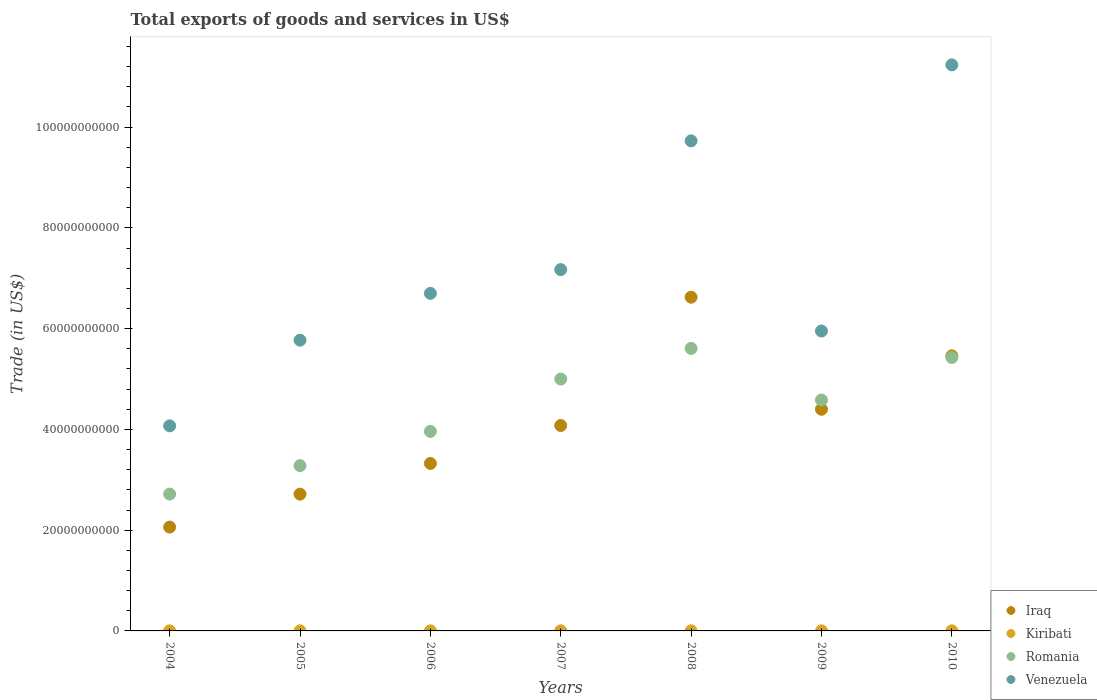How many different coloured dotlines are there?
Offer a very short reply. 4. What is the total exports of goods and services in Kiribati in 2010?
Your answer should be compact. 1.63e+07. Across all years, what is the maximum total exports of goods and services in Kiribati?
Ensure brevity in your answer.  2.08e+07. Across all years, what is the minimum total exports of goods and services in Venezuela?
Your answer should be compact. 4.07e+1. In which year was the total exports of goods and services in Venezuela minimum?
Your response must be concise. 2004. What is the total total exports of goods and services in Venezuela in the graph?
Offer a terse response. 5.06e+11. What is the difference between the total exports of goods and services in Venezuela in 2004 and that in 2007?
Make the answer very short. -3.10e+1. What is the difference between the total exports of goods and services in Iraq in 2004 and the total exports of goods and services in Kiribati in 2005?
Provide a succinct answer. 2.06e+1. What is the average total exports of goods and services in Romania per year?
Your response must be concise. 4.37e+1. In the year 2008, what is the difference between the total exports of goods and services in Iraq and total exports of goods and services in Kiribati?
Offer a terse response. 6.62e+1. In how many years, is the total exports of goods and services in Kiribati greater than 8000000000 US$?
Provide a short and direct response. 0. What is the ratio of the total exports of goods and services in Iraq in 2008 to that in 2009?
Give a very brief answer. 1.51. Is the total exports of goods and services in Romania in 2004 less than that in 2005?
Your response must be concise. Yes. What is the difference between the highest and the second highest total exports of goods and services in Venezuela?
Offer a very short reply. 1.51e+1. What is the difference between the highest and the lowest total exports of goods and services in Venezuela?
Ensure brevity in your answer.  7.16e+1. In how many years, is the total exports of goods and services in Kiribati greater than the average total exports of goods and services in Kiribati taken over all years?
Give a very brief answer. 4. Is the sum of the total exports of goods and services in Venezuela in 2009 and 2010 greater than the maximum total exports of goods and services in Romania across all years?
Ensure brevity in your answer.  Yes. Is it the case that in every year, the sum of the total exports of goods and services in Kiribati and total exports of goods and services in Venezuela  is greater than the sum of total exports of goods and services in Romania and total exports of goods and services in Iraq?
Your answer should be very brief. Yes. Is it the case that in every year, the sum of the total exports of goods and services in Romania and total exports of goods and services in Kiribati  is greater than the total exports of goods and services in Iraq?
Your answer should be very brief. No. Does the total exports of goods and services in Iraq monotonically increase over the years?
Ensure brevity in your answer.  No. Is the total exports of goods and services in Iraq strictly greater than the total exports of goods and services in Venezuela over the years?
Make the answer very short. No. How many dotlines are there?
Make the answer very short. 4. Does the graph contain any zero values?
Your answer should be compact. No. Where does the legend appear in the graph?
Provide a succinct answer. Bottom right. How many legend labels are there?
Ensure brevity in your answer.  4. What is the title of the graph?
Provide a succinct answer. Total exports of goods and services in US$. Does "Nepal" appear as one of the legend labels in the graph?
Your answer should be very brief. No. What is the label or title of the Y-axis?
Make the answer very short. Trade (in US$). What is the Trade (in US$) in Iraq in 2004?
Give a very brief answer. 2.06e+1. What is the Trade (in US$) of Kiribati in 2004?
Provide a succinct answer. 1.19e+07. What is the Trade (in US$) of Romania in 2004?
Provide a short and direct response. 2.72e+1. What is the Trade (in US$) in Venezuela in 2004?
Offer a terse response. 4.07e+1. What is the Trade (in US$) in Iraq in 2005?
Your response must be concise. 2.71e+1. What is the Trade (in US$) of Kiribati in 2005?
Your answer should be compact. 1.50e+07. What is the Trade (in US$) in Romania in 2005?
Provide a short and direct response. 3.28e+1. What is the Trade (in US$) of Venezuela in 2005?
Offer a terse response. 5.77e+1. What is the Trade (in US$) in Iraq in 2006?
Keep it short and to the point. 3.32e+1. What is the Trade (in US$) of Kiribati in 2006?
Give a very brief answer. 1.14e+07. What is the Trade (in US$) in Romania in 2006?
Offer a terse response. 3.96e+1. What is the Trade (in US$) in Venezuela in 2006?
Your answer should be compact. 6.70e+1. What is the Trade (in US$) of Iraq in 2007?
Your answer should be compact. 4.08e+1. What is the Trade (in US$) in Kiribati in 2007?
Provide a short and direct response. 2.08e+07. What is the Trade (in US$) of Romania in 2007?
Keep it short and to the point. 5.00e+1. What is the Trade (in US$) in Venezuela in 2007?
Keep it short and to the point. 7.17e+1. What is the Trade (in US$) of Iraq in 2008?
Offer a terse response. 6.62e+1. What is the Trade (in US$) of Kiribati in 2008?
Your answer should be very brief. 1.90e+07. What is the Trade (in US$) in Romania in 2008?
Keep it short and to the point. 5.61e+1. What is the Trade (in US$) in Venezuela in 2008?
Give a very brief answer. 9.73e+1. What is the Trade (in US$) of Iraq in 2009?
Your answer should be compact. 4.40e+1. What is the Trade (in US$) in Kiribati in 2009?
Offer a terse response. 1.82e+07. What is the Trade (in US$) of Romania in 2009?
Offer a very short reply. 4.58e+1. What is the Trade (in US$) in Venezuela in 2009?
Keep it short and to the point. 5.95e+1. What is the Trade (in US$) of Iraq in 2010?
Give a very brief answer. 5.46e+1. What is the Trade (in US$) in Kiribati in 2010?
Ensure brevity in your answer.  1.63e+07. What is the Trade (in US$) in Romania in 2010?
Give a very brief answer. 5.43e+1. What is the Trade (in US$) in Venezuela in 2010?
Ensure brevity in your answer.  1.12e+11. Across all years, what is the maximum Trade (in US$) in Iraq?
Your response must be concise. 6.62e+1. Across all years, what is the maximum Trade (in US$) of Kiribati?
Offer a terse response. 2.08e+07. Across all years, what is the maximum Trade (in US$) of Romania?
Make the answer very short. 5.61e+1. Across all years, what is the maximum Trade (in US$) of Venezuela?
Ensure brevity in your answer.  1.12e+11. Across all years, what is the minimum Trade (in US$) in Iraq?
Ensure brevity in your answer.  2.06e+1. Across all years, what is the minimum Trade (in US$) in Kiribati?
Your answer should be very brief. 1.14e+07. Across all years, what is the minimum Trade (in US$) in Romania?
Offer a terse response. 2.72e+1. Across all years, what is the minimum Trade (in US$) of Venezuela?
Give a very brief answer. 4.07e+1. What is the total Trade (in US$) in Iraq in the graph?
Your response must be concise. 2.87e+11. What is the total Trade (in US$) in Kiribati in the graph?
Keep it short and to the point. 1.13e+08. What is the total Trade (in US$) of Romania in the graph?
Offer a terse response. 3.06e+11. What is the total Trade (in US$) in Venezuela in the graph?
Offer a very short reply. 5.06e+11. What is the difference between the Trade (in US$) of Iraq in 2004 and that in 2005?
Your response must be concise. -6.54e+09. What is the difference between the Trade (in US$) in Kiribati in 2004 and that in 2005?
Provide a succinct answer. -3.09e+06. What is the difference between the Trade (in US$) of Romania in 2004 and that in 2005?
Your answer should be compact. -5.65e+09. What is the difference between the Trade (in US$) in Venezuela in 2004 and that in 2005?
Your answer should be very brief. -1.70e+1. What is the difference between the Trade (in US$) of Iraq in 2004 and that in 2006?
Offer a terse response. -1.26e+1. What is the difference between the Trade (in US$) of Kiribati in 2004 and that in 2006?
Keep it short and to the point. 4.48e+05. What is the difference between the Trade (in US$) of Romania in 2004 and that in 2006?
Provide a succinct answer. -1.24e+1. What is the difference between the Trade (in US$) of Venezuela in 2004 and that in 2006?
Give a very brief answer. -2.63e+1. What is the difference between the Trade (in US$) of Iraq in 2004 and that in 2007?
Keep it short and to the point. -2.02e+1. What is the difference between the Trade (in US$) of Kiribati in 2004 and that in 2007?
Your answer should be compact. -8.93e+06. What is the difference between the Trade (in US$) of Romania in 2004 and that in 2007?
Provide a succinct answer. -2.28e+1. What is the difference between the Trade (in US$) in Venezuela in 2004 and that in 2007?
Your answer should be compact. -3.10e+1. What is the difference between the Trade (in US$) of Iraq in 2004 and that in 2008?
Keep it short and to the point. -4.56e+1. What is the difference between the Trade (in US$) of Kiribati in 2004 and that in 2008?
Keep it short and to the point. -7.11e+06. What is the difference between the Trade (in US$) in Romania in 2004 and that in 2008?
Keep it short and to the point. -2.89e+1. What is the difference between the Trade (in US$) of Venezuela in 2004 and that in 2008?
Keep it short and to the point. -5.66e+1. What is the difference between the Trade (in US$) of Iraq in 2004 and that in 2009?
Give a very brief answer. -2.34e+1. What is the difference between the Trade (in US$) of Kiribati in 2004 and that in 2009?
Your answer should be compact. -6.35e+06. What is the difference between the Trade (in US$) of Romania in 2004 and that in 2009?
Give a very brief answer. -1.87e+1. What is the difference between the Trade (in US$) in Venezuela in 2004 and that in 2009?
Give a very brief answer. -1.88e+1. What is the difference between the Trade (in US$) of Iraq in 2004 and that in 2010?
Your response must be concise. -3.40e+1. What is the difference between the Trade (in US$) of Kiribati in 2004 and that in 2010?
Offer a very short reply. -4.45e+06. What is the difference between the Trade (in US$) of Romania in 2004 and that in 2010?
Your response must be concise. -2.71e+1. What is the difference between the Trade (in US$) in Venezuela in 2004 and that in 2010?
Offer a terse response. -7.16e+1. What is the difference between the Trade (in US$) of Iraq in 2005 and that in 2006?
Your answer should be very brief. -6.09e+09. What is the difference between the Trade (in US$) in Kiribati in 2005 and that in 2006?
Provide a succinct answer. 3.54e+06. What is the difference between the Trade (in US$) in Romania in 2005 and that in 2006?
Keep it short and to the point. -6.80e+09. What is the difference between the Trade (in US$) of Venezuela in 2005 and that in 2006?
Give a very brief answer. -9.29e+09. What is the difference between the Trade (in US$) of Iraq in 2005 and that in 2007?
Offer a terse response. -1.36e+1. What is the difference between the Trade (in US$) of Kiribati in 2005 and that in 2007?
Make the answer very short. -5.84e+06. What is the difference between the Trade (in US$) in Romania in 2005 and that in 2007?
Make the answer very short. -1.72e+1. What is the difference between the Trade (in US$) in Venezuela in 2005 and that in 2007?
Your response must be concise. -1.40e+1. What is the difference between the Trade (in US$) of Iraq in 2005 and that in 2008?
Your answer should be very brief. -3.91e+1. What is the difference between the Trade (in US$) of Kiribati in 2005 and that in 2008?
Give a very brief answer. -4.02e+06. What is the difference between the Trade (in US$) of Romania in 2005 and that in 2008?
Provide a short and direct response. -2.33e+1. What is the difference between the Trade (in US$) in Venezuela in 2005 and that in 2008?
Make the answer very short. -3.96e+1. What is the difference between the Trade (in US$) in Iraq in 2005 and that in 2009?
Offer a very short reply. -1.68e+1. What is the difference between the Trade (in US$) of Kiribati in 2005 and that in 2009?
Provide a succinct answer. -3.26e+06. What is the difference between the Trade (in US$) in Romania in 2005 and that in 2009?
Provide a succinct answer. -1.30e+1. What is the difference between the Trade (in US$) of Venezuela in 2005 and that in 2009?
Offer a terse response. -1.82e+09. What is the difference between the Trade (in US$) of Iraq in 2005 and that in 2010?
Keep it short and to the point. -2.74e+1. What is the difference between the Trade (in US$) of Kiribati in 2005 and that in 2010?
Your answer should be compact. -1.35e+06. What is the difference between the Trade (in US$) of Romania in 2005 and that in 2010?
Your response must be concise. -2.15e+1. What is the difference between the Trade (in US$) in Venezuela in 2005 and that in 2010?
Offer a very short reply. -5.46e+1. What is the difference between the Trade (in US$) of Iraq in 2006 and that in 2007?
Offer a very short reply. -7.54e+09. What is the difference between the Trade (in US$) of Kiribati in 2006 and that in 2007?
Your answer should be compact. -9.38e+06. What is the difference between the Trade (in US$) in Romania in 2006 and that in 2007?
Your answer should be very brief. -1.04e+1. What is the difference between the Trade (in US$) of Venezuela in 2006 and that in 2007?
Offer a very short reply. -4.71e+09. What is the difference between the Trade (in US$) in Iraq in 2006 and that in 2008?
Offer a terse response. -3.30e+1. What is the difference between the Trade (in US$) in Kiribati in 2006 and that in 2008?
Ensure brevity in your answer.  -7.56e+06. What is the difference between the Trade (in US$) of Romania in 2006 and that in 2008?
Keep it short and to the point. -1.65e+1. What is the difference between the Trade (in US$) in Venezuela in 2006 and that in 2008?
Your answer should be very brief. -3.03e+1. What is the difference between the Trade (in US$) of Iraq in 2006 and that in 2009?
Provide a short and direct response. -1.08e+1. What is the difference between the Trade (in US$) of Kiribati in 2006 and that in 2009?
Make the answer very short. -6.80e+06. What is the difference between the Trade (in US$) of Romania in 2006 and that in 2009?
Your response must be concise. -6.22e+09. What is the difference between the Trade (in US$) of Venezuela in 2006 and that in 2009?
Ensure brevity in your answer.  7.47e+09. What is the difference between the Trade (in US$) of Iraq in 2006 and that in 2010?
Keep it short and to the point. -2.14e+1. What is the difference between the Trade (in US$) in Kiribati in 2006 and that in 2010?
Your answer should be compact. -4.89e+06. What is the difference between the Trade (in US$) of Romania in 2006 and that in 2010?
Offer a terse response. -1.47e+1. What is the difference between the Trade (in US$) of Venezuela in 2006 and that in 2010?
Provide a short and direct response. -4.53e+1. What is the difference between the Trade (in US$) of Iraq in 2007 and that in 2008?
Your response must be concise. -2.55e+1. What is the difference between the Trade (in US$) in Kiribati in 2007 and that in 2008?
Provide a succinct answer. 1.82e+06. What is the difference between the Trade (in US$) in Romania in 2007 and that in 2008?
Make the answer very short. -6.08e+09. What is the difference between the Trade (in US$) in Venezuela in 2007 and that in 2008?
Your answer should be compact. -2.56e+1. What is the difference between the Trade (in US$) in Iraq in 2007 and that in 2009?
Offer a very short reply. -3.22e+09. What is the difference between the Trade (in US$) in Kiribati in 2007 and that in 2009?
Keep it short and to the point. 2.59e+06. What is the difference between the Trade (in US$) in Romania in 2007 and that in 2009?
Offer a very short reply. 4.17e+09. What is the difference between the Trade (in US$) of Venezuela in 2007 and that in 2009?
Ensure brevity in your answer.  1.22e+1. What is the difference between the Trade (in US$) in Iraq in 2007 and that in 2010?
Offer a very short reply. -1.38e+1. What is the difference between the Trade (in US$) in Kiribati in 2007 and that in 2010?
Make the answer very short. 4.49e+06. What is the difference between the Trade (in US$) of Romania in 2007 and that in 2010?
Your response must be concise. -4.27e+09. What is the difference between the Trade (in US$) in Venezuela in 2007 and that in 2010?
Give a very brief answer. -4.06e+1. What is the difference between the Trade (in US$) of Iraq in 2008 and that in 2009?
Your answer should be very brief. 2.22e+1. What is the difference between the Trade (in US$) in Kiribati in 2008 and that in 2009?
Ensure brevity in your answer.  7.68e+05. What is the difference between the Trade (in US$) of Romania in 2008 and that in 2009?
Give a very brief answer. 1.02e+1. What is the difference between the Trade (in US$) of Venezuela in 2008 and that in 2009?
Keep it short and to the point. 3.77e+1. What is the difference between the Trade (in US$) of Iraq in 2008 and that in 2010?
Your response must be concise. 1.16e+1. What is the difference between the Trade (in US$) in Kiribati in 2008 and that in 2010?
Keep it short and to the point. 2.67e+06. What is the difference between the Trade (in US$) in Romania in 2008 and that in 2010?
Provide a short and direct response. 1.81e+09. What is the difference between the Trade (in US$) in Venezuela in 2008 and that in 2010?
Offer a very short reply. -1.51e+1. What is the difference between the Trade (in US$) of Iraq in 2009 and that in 2010?
Ensure brevity in your answer.  -1.06e+1. What is the difference between the Trade (in US$) in Kiribati in 2009 and that in 2010?
Provide a short and direct response. 1.90e+06. What is the difference between the Trade (in US$) of Romania in 2009 and that in 2010?
Your answer should be very brief. -8.44e+09. What is the difference between the Trade (in US$) in Venezuela in 2009 and that in 2010?
Your response must be concise. -5.28e+1. What is the difference between the Trade (in US$) in Iraq in 2004 and the Trade (in US$) in Kiribati in 2005?
Your response must be concise. 2.06e+1. What is the difference between the Trade (in US$) in Iraq in 2004 and the Trade (in US$) in Romania in 2005?
Your answer should be compact. -1.22e+1. What is the difference between the Trade (in US$) of Iraq in 2004 and the Trade (in US$) of Venezuela in 2005?
Your response must be concise. -3.71e+1. What is the difference between the Trade (in US$) in Kiribati in 2004 and the Trade (in US$) in Romania in 2005?
Ensure brevity in your answer.  -3.28e+1. What is the difference between the Trade (in US$) in Kiribati in 2004 and the Trade (in US$) in Venezuela in 2005?
Ensure brevity in your answer.  -5.77e+1. What is the difference between the Trade (in US$) of Romania in 2004 and the Trade (in US$) of Venezuela in 2005?
Offer a terse response. -3.05e+1. What is the difference between the Trade (in US$) in Iraq in 2004 and the Trade (in US$) in Kiribati in 2006?
Ensure brevity in your answer.  2.06e+1. What is the difference between the Trade (in US$) of Iraq in 2004 and the Trade (in US$) of Romania in 2006?
Give a very brief answer. -1.90e+1. What is the difference between the Trade (in US$) in Iraq in 2004 and the Trade (in US$) in Venezuela in 2006?
Provide a short and direct response. -4.64e+1. What is the difference between the Trade (in US$) in Kiribati in 2004 and the Trade (in US$) in Romania in 2006?
Offer a terse response. -3.96e+1. What is the difference between the Trade (in US$) of Kiribati in 2004 and the Trade (in US$) of Venezuela in 2006?
Your answer should be compact. -6.70e+1. What is the difference between the Trade (in US$) in Romania in 2004 and the Trade (in US$) in Venezuela in 2006?
Keep it short and to the point. -3.98e+1. What is the difference between the Trade (in US$) of Iraq in 2004 and the Trade (in US$) of Kiribati in 2007?
Give a very brief answer. 2.06e+1. What is the difference between the Trade (in US$) of Iraq in 2004 and the Trade (in US$) of Romania in 2007?
Provide a succinct answer. -2.94e+1. What is the difference between the Trade (in US$) in Iraq in 2004 and the Trade (in US$) in Venezuela in 2007?
Make the answer very short. -5.11e+1. What is the difference between the Trade (in US$) of Kiribati in 2004 and the Trade (in US$) of Romania in 2007?
Your response must be concise. -5.00e+1. What is the difference between the Trade (in US$) in Kiribati in 2004 and the Trade (in US$) in Venezuela in 2007?
Keep it short and to the point. -7.17e+1. What is the difference between the Trade (in US$) of Romania in 2004 and the Trade (in US$) of Venezuela in 2007?
Offer a very short reply. -4.46e+1. What is the difference between the Trade (in US$) in Iraq in 2004 and the Trade (in US$) in Kiribati in 2008?
Provide a short and direct response. 2.06e+1. What is the difference between the Trade (in US$) in Iraq in 2004 and the Trade (in US$) in Romania in 2008?
Offer a very short reply. -3.55e+1. What is the difference between the Trade (in US$) of Iraq in 2004 and the Trade (in US$) of Venezuela in 2008?
Make the answer very short. -7.67e+1. What is the difference between the Trade (in US$) in Kiribati in 2004 and the Trade (in US$) in Romania in 2008?
Offer a very short reply. -5.61e+1. What is the difference between the Trade (in US$) of Kiribati in 2004 and the Trade (in US$) of Venezuela in 2008?
Offer a terse response. -9.73e+1. What is the difference between the Trade (in US$) in Romania in 2004 and the Trade (in US$) in Venezuela in 2008?
Ensure brevity in your answer.  -7.01e+1. What is the difference between the Trade (in US$) of Iraq in 2004 and the Trade (in US$) of Kiribati in 2009?
Provide a short and direct response. 2.06e+1. What is the difference between the Trade (in US$) in Iraq in 2004 and the Trade (in US$) in Romania in 2009?
Your response must be concise. -2.52e+1. What is the difference between the Trade (in US$) in Iraq in 2004 and the Trade (in US$) in Venezuela in 2009?
Your response must be concise. -3.89e+1. What is the difference between the Trade (in US$) in Kiribati in 2004 and the Trade (in US$) in Romania in 2009?
Provide a succinct answer. -4.58e+1. What is the difference between the Trade (in US$) in Kiribati in 2004 and the Trade (in US$) in Venezuela in 2009?
Offer a very short reply. -5.95e+1. What is the difference between the Trade (in US$) of Romania in 2004 and the Trade (in US$) of Venezuela in 2009?
Ensure brevity in your answer.  -3.24e+1. What is the difference between the Trade (in US$) in Iraq in 2004 and the Trade (in US$) in Kiribati in 2010?
Provide a succinct answer. 2.06e+1. What is the difference between the Trade (in US$) of Iraq in 2004 and the Trade (in US$) of Romania in 2010?
Your response must be concise. -3.37e+1. What is the difference between the Trade (in US$) in Iraq in 2004 and the Trade (in US$) in Venezuela in 2010?
Offer a terse response. -9.17e+1. What is the difference between the Trade (in US$) in Kiribati in 2004 and the Trade (in US$) in Romania in 2010?
Keep it short and to the point. -5.43e+1. What is the difference between the Trade (in US$) of Kiribati in 2004 and the Trade (in US$) of Venezuela in 2010?
Give a very brief answer. -1.12e+11. What is the difference between the Trade (in US$) in Romania in 2004 and the Trade (in US$) in Venezuela in 2010?
Make the answer very short. -8.52e+1. What is the difference between the Trade (in US$) in Iraq in 2005 and the Trade (in US$) in Kiribati in 2006?
Your response must be concise. 2.71e+1. What is the difference between the Trade (in US$) in Iraq in 2005 and the Trade (in US$) in Romania in 2006?
Offer a very short reply. -1.25e+1. What is the difference between the Trade (in US$) of Iraq in 2005 and the Trade (in US$) of Venezuela in 2006?
Make the answer very short. -3.99e+1. What is the difference between the Trade (in US$) in Kiribati in 2005 and the Trade (in US$) in Romania in 2006?
Make the answer very short. -3.96e+1. What is the difference between the Trade (in US$) of Kiribati in 2005 and the Trade (in US$) of Venezuela in 2006?
Give a very brief answer. -6.70e+1. What is the difference between the Trade (in US$) in Romania in 2005 and the Trade (in US$) in Venezuela in 2006?
Offer a terse response. -3.42e+1. What is the difference between the Trade (in US$) in Iraq in 2005 and the Trade (in US$) in Kiribati in 2007?
Ensure brevity in your answer.  2.71e+1. What is the difference between the Trade (in US$) in Iraq in 2005 and the Trade (in US$) in Romania in 2007?
Offer a terse response. -2.28e+1. What is the difference between the Trade (in US$) of Iraq in 2005 and the Trade (in US$) of Venezuela in 2007?
Ensure brevity in your answer.  -4.46e+1. What is the difference between the Trade (in US$) of Kiribati in 2005 and the Trade (in US$) of Romania in 2007?
Provide a succinct answer. -5.00e+1. What is the difference between the Trade (in US$) of Kiribati in 2005 and the Trade (in US$) of Venezuela in 2007?
Offer a terse response. -7.17e+1. What is the difference between the Trade (in US$) of Romania in 2005 and the Trade (in US$) of Venezuela in 2007?
Ensure brevity in your answer.  -3.89e+1. What is the difference between the Trade (in US$) of Iraq in 2005 and the Trade (in US$) of Kiribati in 2008?
Your answer should be compact. 2.71e+1. What is the difference between the Trade (in US$) of Iraq in 2005 and the Trade (in US$) of Romania in 2008?
Your answer should be compact. -2.89e+1. What is the difference between the Trade (in US$) of Iraq in 2005 and the Trade (in US$) of Venezuela in 2008?
Provide a succinct answer. -7.01e+1. What is the difference between the Trade (in US$) in Kiribati in 2005 and the Trade (in US$) in Romania in 2008?
Make the answer very short. -5.61e+1. What is the difference between the Trade (in US$) of Kiribati in 2005 and the Trade (in US$) of Venezuela in 2008?
Make the answer very short. -9.73e+1. What is the difference between the Trade (in US$) in Romania in 2005 and the Trade (in US$) in Venezuela in 2008?
Give a very brief answer. -6.45e+1. What is the difference between the Trade (in US$) in Iraq in 2005 and the Trade (in US$) in Kiribati in 2009?
Your answer should be compact. 2.71e+1. What is the difference between the Trade (in US$) of Iraq in 2005 and the Trade (in US$) of Romania in 2009?
Keep it short and to the point. -1.87e+1. What is the difference between the Trade (in US$) of Iraq in 2005 and the Trade (in US$) of Venezuela in 2009?
Your answer should be compact. -3.24e+1. What is the difference between the Trade (in US$) of Kiribati in 2005 and the Trade (in US$) of Romania in 2009?
Keep it short and to the point. -4.58e+1. What is the difference between the Trade (in US$) in Kiribati in 2005 and the Trade (in US$) in Venezuela in 2009?
Make the answer very short. -5.95e+1. What is the difference between the Trade (in US$) of Romania in 2005 and the Trade (in US$) of Venezuela in 2009?
Your answer should be very brief. -2.67e+1. What is the difference between the Trade (in US$) of Iraq in 2005 and the Trade (in US$) of Kiribati in 2010?
Your response must be concise. 2.71e+1. What is the difference between the Trade (in US$) of Iraq in 2005 and the Trade (in US$) of Romania in 2010?
Keep it short and to the point. -2.71e+1. What is the difference between the Trade (in US$) of Iraq in 2005 and the Trade (in US$) of Venezuela in 2010?
Keep it short and to the point. -8.52e+1. What is the difference between the Trade (in US$) in Kiribati in 2005 and the Trade (in US$) in Romania in 2010?
Your answer should be compact. -5.43e+1. What is the difference between the Trade (in US$) of Kiribati in 2005 and the Trade (in US$) of Venezuela in 2010?
Provide a short and direct response. -1.12e+11. What is the difference between the Trade (in US$) in Romania in 2005 and the Trade (in US$) in Venezuela in 2010?
Provide a short and direct response. -7.95e+1. What is the difference between the Trade (in US$) in Iraq in 2006 and the Trade (in US$) in Kiribati in 2007?
Your response must be concise. 3.32e+1. What is the difference between the Trade (in US$) in Iraq in 2006 and the Trade (in US$) in Romania in 2007?
Your answer should be compact. -1.68e+1. What is the difference between the Trade (in US$) of Iraq in 2006 and the Trade (in US$) of Venezuela in 2007?
Ensure brevity in your answer.  -3.85e+1. What is the difference between the Trade (in US$) of Kiribati in 2006 and the Trade (in US$) of Romania in 2007?
Make the answer very short. -5.00e+1. What is the difference between the Trade (in US$) of Kiribati in 2006 and the Trade (in US$) of Venezuela in 2007?
Your response must be concise. -7.17e+1. What is the difference between the Trade (in US$) of Romania in 2006 and the Trade (in US$) of Venezuela in 2007?
Give a very brief answer. -3.21e+1. What is the difference between the Trade (in US$) of Iraq in 2006 and the Trade (in US$) of Kiribati in 2008?
Make the answer very short. 3.32e+1. What is the difference between the Trade (in US$) in Iraq in 2006 and the Trade (in US$) in Romania in 2008?
Your answer should be very brief. -2.28e+1. What is the difference between the Trade (in US$) of Iraq in 2006 and the Trade (in US$) of Venezuela in 2008?
Provide a short and direct response. -6.40e+1. What is the difference between the Trade (in US$) in Kiribati in 2006 and the Trade (in US$) in Romania in 2008?
Offer a terse response. -5.61e+1. What is the difference between the Trade (in US$) in Kiribati in 2006 and the Trade (in US$) in Venezuela in 2008?
Provide a short and direct response. -9.73e+1. What is the difference between the Trade (in US$) of Romania in 2006 and the Trade (in US$) of Venezuela in 2008?
Ensure brevity in your answer.  -5.77e+1. What is the difference between the Trade (in US$) of Iraq in 2006 and the Trade (in US$) of Kiribati in 2009?
Ensure brevity in your answer.  3.32e+1. What is the difference between the Trade (in US$) in Iraq in 2006 and the Trade (in US$) in Romania in 2009?
Your answer should be very brief. -1.26e+1. What is the difference between the Trade (in US$) in Iraq in 2006 and the Trade (in US$) in Venezuela in 2009?
Your answer should be compact. -2.63e+1. What is the difference between the Trade (in US$) of Kiribati in 2006 and the Trade (in US$) of Romania in 2009?
Your answer should be very brief. -4.58e+1. What is the difference between the Trade (in US$) of Kiribati in 2006 and the Trade (in US$) of Venezuela in 2009?
Your answer should be compact. -5.95e+1. What is the difference between the Trade (in US$) of Romania in 2006 and the Trade (in US$) of Venezuela in 2009?
Offer a terse response. -1.99e+1. What is the difference between the Trade (in US$) in Iraq in 2006 and the Trade (in US$) in Kiribati in 2010?
Give a very brief answer. 3.32e+1. What is the difference between the Trade (in US$) in Iraq in 2006 and the Trade (in US$) in Romania in 2010?
Provide a short and direct response. -2.10e+1. What is the difference between the Trade (in US$) of Iraq in 2006 and the Trade (in US$) of Venezuela in 2010?
Give a very brief answer. -7.91e+1. What is the difference between the Trade (in US$) of Kiribati in 2006 and the Trade (in US$) of Romania in 2010?
Make the answer very short. -5.43e+1. What is the difference between the Trade (in US$) in Kiribati in 2006 and the Trade (in US$) in Venezuela in 2010?
Ensure brevity in your answer.  -1.12e+11. What is the difference between the Trade (in US$) in Romania in 2006 and the Trade (in US$) in Venezuela in 2010?
Your answer should be very brief. -7.27e+1. What is the difference between the Trade (in US$) in Iraq in 2007 and the Trade (in US$) in Kiribati in 2008?
Ensure brevity in your answer.  4.08e+1. What is the difference between the Trade (in US$) of Iraq in 2007 and the Trade (in US$) of Romania in 2008?
Your answer should be very brief. -1.53e+1. What is the difference between the Trade (in US$) in Iraq in 2007 and the Trade (in US$) in Venezuela in 2008?
Keep it short and to the point. -5.65e+1. What is the difference between the Trade (in US$) in Kiribati in 2007 and the Trade (in US$) in Romania in 2008?
Ensure brevity in your answer.  -5.61e+1. What is the difference between the Trade (in US$) in Kiribati in 2007 and the Trade (in US$) in Venezuela in 2008?
Offer a terse response. -9.73e+1. What is the difference between the Trade (in US$) of Romania in 2007 and the Trade (in US$) of Venezuela in 2008?
Ensure brevity in your answer.  -4.73e+1. What is the difference between the Trade (in US$) in Iraq in 2007 and the Trade (in US$) in Kiribati in 2009?
Your response must be concise. 4.08e+1. What is the difference between the Trade (in US$) in Iraq in 2007 and the Trade (in US$) in Romania in 2009?
Keep it short and to the point. -5.05e+09. What is the difference between the Trade (in US$) in Iraq in 2007 and the Trade (in US$) in Venezuela in 2009?
Keep it short and to the point. -1.88e+1. What is the difference between the Trade (in US$) of Kiribati in 2007 and the Trade (in US$) of Romania in 2009?
Your answer should be compact. -4.58e+1. What is the difference between the Trade (in US$) of Kiribati in 2007 and the Trade (in US$) of Venezuela in 2009?
Your answer should be compact. -5.95e+1. What is the difference between the Trade (in US$) in Romania in 2007 and the Trade (in US$) in Venezuela in 2009?
Offer a terse response. -9.54e+09. What is the difference between the Trade (in US$) in Iraq in 2007 and the Trade (in US$) in Kiribati in 2010?
Your response must be concise. 4.08e+1. What is the difference between the Trade (in US$) of Iraq in 2007 and the Trade (in US$) of Romania in 2010?
Your answer should be compact. -1.35e+1. What is the difference between the Trade (in US$) of Iraq in 2007 and the Trade (in US$) of Venezuela in 2010?
Offer a terse response. -7.16e+1. What is the difference between the Trade (in US$) in Kiribati in 2007 and the Trade (in US$) in Romania in 2010?
Offer a very short reply. -5.42e+1. What is the difference between the Trade (in US$) in Kiribati in 2007 and the Trade (in US$) in Venezuela in 2010?
Offer a very short reply. -1.12e+11. What is the difference between the Trade (in US$) in Romania in 2007 and the Trade (in US$) in Venezuela in 2010?
Ensure brevity in your answer.  -6.24e+1. What is the difference between the Trade (in US$) of Iraq in 2008 and the Trade (in US$) of Kiribati in 2009?
Keep it short and to the point. 6.62e+1. What is the difference between the Trade (in US$) in Iraq in 2008 and the Trade (in US$) in Romania in 2009?
Make the answer very short. 2.04e+1. What is the difference between the Trade (in US$) in Iraq in 2008 and the Trade (in US$) in Venezuela in 2009?
Provide a succinct answer. 6.71e+09. What is the difference between the Trade (in US$) in Kiribati in 2008 and the Trade (in US$) in Romania in 2009?
Ensure brevity in your answer.  -4.58e+1. What is the difference between the Trade (in US$) of Kiribati in 2008 and the Trade (in US$) of Venezuela in 2009?
Your answer should be very brief. -5.95e+1. What is the difference between the Trade (in US$) in Romania in 2008 and the Trade (in US$) in Venezuela in 2009?
Ensure brevity in your answer.  -3.46e+09. What is the difference between the Trade (in US$) in Iraq in 2008 and the Trade (in US$) in Kiribati in 2010?
Ensure brevity in your answer.  6.62e+1. What is the difference between the Trade (in US$) of Iraq in 2008 and the Trade (in US$) of Romania in 2010?
Provide a succinct answer. 1.20e+1. What is the difference between the Trade (in US$) in Iraq in 2008 and the Trade (in US$) in Venezuela in 2010?
Give a very brief answer. -4.61e+1. What is the difference between the Trade (in US$) of Kiribati in 2008 and the Trade (in US$) of Romania in 2010?
Give a very brief answer. -5.42e+1. What is the difference between the Trade (in US$) of Kiribati in 2008 and the Trade (in US$) of Venezuela in 2010?
Offer a very short reply. -1.12e+11. What is the difference between the Trade (in US$) of Romania in 2008 and the Trade (in US$) of Venezuela in 2010?
Provide a succinct answer. -5.63e+1. What is the difference between the Trade (in US$) of Iraq in 2009 and the Trade (in US$) of Kiribati in 2010?
Provide a succinct answer. 4.40e+1. What is the difference between the Trade (in US$) of Iraq in 2009 and the Trade (in US$) of Romania in 2010?
Provide a short and direct response. -1.03e+1. What is the difference between the Trade (in US$) of Iraq in 2009 and the Trade (in US$) of Venezuela in 2010?
Make the answer very short. -6.84e+1. What is the difference between the Trade (in US$) of Kiribati in 2009 and the Trade (in US$) of Romania in 2010?
Ensure brevity in your answer.  -5.42e+1. What is the difference between the Trade (in US$) in Kiribati in 2009 and the Trade (in US$) in Venezuela in 2010?
Offer a very short reply. -1.12e+11. What is the difference between the Trade (in US$) in Romania in 2009 and the Trade (in US$) in Venezuela in 2010?
Offer a terse response. -6.65e+1. What is the average Trade (in US$) in Iraq per year?
Your answer should be very brief. 4.09e+1. What is the average Trade (in US$) in Kiribati per year?
Your response must be concise. 1.61e+07. What is the average Trade (in US$) of Romania per year?
Give a very brief answer. 4.37e+1. What is the average Trade (in US$) of Venezuela per year?
Make the answer very short. 7.23e+1. In the year 2004, what is the difference between the Trade (in US$) in Iraq and Trade (in US$) in Kiribati?
Ensure brevity in your answer.  2.06e+1. In the year 2004, what is the difference between the Trade (in US$) of Iraq and Trade (in US$) of Romania?
Ensure brevity in your answer.  -6.55e+09. In the year 2004, what is the difference between the Trade (in US$) of Iraq and Trade (in US$) of Venezuela?
Offer a terse response. -2.01e+1. In the year 2004, what is the difference between the Trade (in US$) in Kiribati and Trade (in US$) in Romania?
Your response must be concise. -2.71e+1. In the year 2004, what is the difference between the Trade (in US$) in Kiribati and Trade (in US$) in Venezuela?
Offer a very short reply. -4.07e+1. In the year 2004, what is the difference between the Trade (in US$) of Romania and Trade (in US$) of Venezuela?
Offer a very short reply. -1.35e+1. In the year 2005, what is the difference between the Trade (in US$) in Iraq and Trade (in US$) in Kiribati?
Provide a succinct answer. 2.71e+1. In the year 2005, what is the difference between the Trade (in US$) of Iraq and Trade (in US$) of Romania?
Ensure brevity in your answer.  -5.66e+09. In the year 2005, what is the difference between the Trade (in US$) in Iraq and Trade (in US$) in Venezuela?
Your response must be concise. -3.06e+1. In the year 2005, what is the difference between the Trade (in US$) of Kiribati and Trade (in US$) of Romania?
Keep it short and to the point. -3.28e+1. In the year 2005, what is the difference between the Trade (in US$) of Kiribati and Trade (in US$) of Venezuela?
Offer a very short reply. -5.77e+1. In the year 2005, what is the difference between the Trade (in US$) of Romania and Trade (in US$) of Venezuela?
Keep it short and to the point. -2.49e+1. In the year 2006, what is the difference between the Trade (in US$) in Iraq and Trade (in US$) in Kiribati?
Your response must be concise. 3.32e+1. In the year 2006, what is the difference between the Trade (in US$) of Iraq and Trade (in US$) of Romania?
Keep it short and to the point. -6.36e+09. In the year 2006, what is the difference between the Trade (in US$) in Iraq and Trade (in US$) in Venezuela?
Offer a very short reply. -3.38e+1. In the year 2006, what is the difference between the Trade (in US$) in Kiribati and Trade (in US$) in Romania?
Provide a short and direct response. -3.96e+1. In the year 2006, what is the difference between the Trade (in US$) in Kiribati and Trade (in US$) in Venezuela?
Keep it short and to the point. -6.70e+1. In the year 2006, what is the difference between the Trade (in US$) of Romania and Trade (in US$) of Venezuela?
Keep it short and to the point. -2.74e+1. In the year 2007, what is the difference between the Trade (in US$) in Iraq and Trade (in US$) in Kiribati?
Your answer should be compact. 4.08e+1. In the year 2007, what is the difference between the Trade (in US$) of Iraq and Trade (in US$) of Romania?
Keep it short and to the point. -9.22e+09. In the year 2007, what is the difference between the Trade (in US$) of Iraq and Trade (in US$) of Venezuela?
Provide a succinct answer. -3.09e+1. In the year 2007, what is the difference between the Trade (in US$) in Kiribati and Trade (in US$) in Romania?
Provide a short and direct response. -5.00e+1. In the year 2007, what is the difference between the Trade (in US$) in Kiribati and Trade (in US$) in Venezuela?
Give a very brief answer. -7.17e+1. In the year 2007, what is the difference between the Trade (in US$) in Romania and Trade (in US$) in Venezuela?
Provide a succinct answer. -2.17e+1. In the year 2008, what is the difference between the Trade (in US$) in Iraq and Trade (in US$) in Kiribati?
Give a very brief answer. 6.62e+1. In the year 2008, what is the difference between the Trade (in US$) in Iraq and Trade (in US$) in Romania?
Keep it short and to the point. 1.02e+1. In the year 2008, what is the difference between the Trade (in US$) in Iraq and Trade (in US$) in Venezuela?
Provide a short and direct response. -3.10e+1. In the year 2008, what is the difference between the Trade (in US$) of Kiribati and Trade (in US$) of Romania?
Offer a terse response. -5.61e+1. In the year 2008, what is the difference between the Trade (in US$) in Kiribati and Trade (in US$) in Venezuela?
Offer a very short reply. -9.73e+1. In the year 2008, what is the difference between the Trade (in US$) in Romania and Trade (in US$) in Venezuela?
Provide a succinct answer. -4.12e+1. In the year 2009, what is the difference between the Trade (in US$) of Iraq and Trade (in US$) of Kiribati?
Offer a terse response. 4.40e+1. In the year 2009, what is the difference between the Trade (in US$) in Iraq and Trade (in US$) in Romania?
Ensure brevity in your answer.  -1.83e+09. In the year 2009, what is the difference between the Trade (in US$) in Iraq and Trade (in US$) in Venezuela?
Offer a terse response. -1.55e+1. In the year 2009, what is the difference between the Trade (in US$) of Kiribati and Trade (in US$) of Romania?
Offer a very short reply. -4.58e+1. In the year 2009, what is the difference between the Trade (in US$) of Kiribati and Trade (in US$) of Venezuela?
Your answer should be very brief. -5.95e+1. In the year 2009, what is the difference between the Trade (in US$) of Romania and Trade (in US$) of Venezuela?
Keep it short and to the point. -1.37e+1. In the year 2010, what is the difference between the Trade (in US$) in Iraq and Trade (in US$) in Kiribati?
Provide a succinct answer. 5.46e+1. In the year 2010, what is the difference between the Trade (in US$) in Iraq and Trade (in US$) in Romania?
Give a very brief answer. 3.32e+08. In the year 2010, what is the difference between the Trade (in US$) in Iraq and Trade (in US$) in Venezuela?
Ensure brevity in your answer.  -5.78e+1. In the year 2010, what is the difference between the Trade (in US$) of Kiribati and Trade (in US$) of Romania?
Offer a very short reply. -5.43e+1. In the year 2010, what is the difference between the Trade (in US$) in Kiribati and Trade (in US$) in Venezuela?
Your answer should be compact. -1.12e+11. In the year 2010, what is the difference between the Trade (in US$) of Romania and Trade (in US$) of Venezuela?
Ensure brevity in your answer.  -5.81e+1. What is the ratio of the Trade (in US$) in Iraq in 2004 to that in 2005?
Provide a succinct answer. 0.76. What is the ratio of the Trade (in US$) in Kiribati in 2004 to that in 2005?
Your response must be concise. 0.79. What is the ratio of the Trade (in US$) of Romania in 2004 to that in 2005?
Offer a very short reply. 0.83. What is the ratio of the Trade (in US$) of Venezuela in 2004 to that in 2005?
Your answer should be very brief. 0.71. What is the ratio of the Trade (in US$) in Iraq in 2004 to that in 2006?
Your answer should be very brief. 0.62. What is the ratio of the Trade (in US$) of Kiribati in 2004 to that in 2006?
Keep it short and to the point. 1.04. What is the ratio of the Trade (in US$) in Romania in 2004 to that in 2006?
Make the answer very short. 0.69. What is the ratio of the Trade (in US$) in Venezuela in 2004 to that in 2006?
Make the answer very short. 0.61. What is the ratio of the Trade (in US$) of Iraq in 2004 to that in 2007?
Ensure brevity in your answer.  0.51. What is the ratio of the Trade (in US$) in Kiribati in 2004 to that in 2007?
Your answer should be compact. 0.57. What is the ratio of the Trade (in US$) of Romania in 2004 to that in 2007?
Your answer should be compact. 0.54. What is the ratio of the Trade (in US$) in Venezuela in 2004 to that in 2007?
Your answer should be compact. 0.57. What is the ratio of the Trade (in US$) in Iraq in 2004 to that in 2008?
Your answer should be compact. 0.31. What is the ratio of the Trade (in US$) of Kiribati in 2004 to that in 2008?
Your answer should be very brief. 0.63. What is the ratio of the Trade (in US$) of Romania in 2004 to that in 2008?
Provide a succinct answer. 0.48. What is the ratio of the Trade (in US$) of Venezuela in 2004 to that in 2008?
Your answer should be very brief. 0.42. What is the ratio of the Trade (in US$) of Iraq in 2004 to that in 2009?
Provide a short and direct response. 0.47. What is the ratio of the Trade (in US$) in Kiribati in 2004 to that in 2009?
Your response must be concise. 0.65. What is the ratio of the Trade (in US$) of Romania in 2004 to that in 2009?
Provide a short and direct response. 0.59. What is the ratio of the Trade (in US$) in Venezuela in 2004 to that in 2009?
Ensure brevity in your answer.  0.68. What is the ratio of the Trade (in US$) of Iraq in 2004 to that in 2010?
Offer a terse response. 0.38. What is the ratio of the Trade (in US$) in Kiribati in 2004 to that in 2010?
Ensure brevity in your answer.  0.73. What is the ratio of the Trade (in US$) of Romania in 2004 to that in 2010?
Make the answer very short. 0.5. What is the ratio of the Trade (in US$) in Venezuela in 2004 to that in 2010?
Provide a short and direct response. 0.36. What is the ratio of the Trade (in US$) of Iraq in 2005 to that in 2006?
Offer a very short reply. 0.82. What is the ratio of the Trade (in US$) in Kiribati in 2005 to that in 2006?
Your answer should be compact. 1.31. What is the ratio of the Trade (in US$) of Romania in 2005 to that in 2006?
Keep it short and to the point. 0.83. What is the ratio of the Trade (in US$) in Venezuela in 2005 to that in 2006?
Provide a short and direct response. 0.86. What is the ratio of the Trade (in US$) of Iraq in 2005 to that in 2007?
Keep it short and to the point. 0.67. What is the ratio of the Trade (in US$) in Kiribati in 2005 to that in 2007?
Offer a very short reply. 0.72. What is the ratio of the Trade (in US$) of Romania in 2005 to that in 2007?
Provide a short and direct response. 0.66. What is the ratio of the Trade (in US$) of Venezuela in 2005 to that in 2007?
Your response must be concise. 0.8. What is the ratio of the Trade (in US$) of Iraq in 2005 to that in 2008?
Keep it short and to the point. 0.41. What is the ratio of the Trade (in US$) in Kiribati in 2005 to that in 2008?
Give a very brief answer. 0.79. What is the ratio of the Trade (in US$) in Romania in 2005 to that in 2008?
Your response must be concise. 0.59. What is the ratio of the Trade (in US$) in Venezuela in 2005 to that in 2008?
Make the answer very short. 0.59. What is the ratio of the Trade (in US$) in Iraq in 2005 to that in 2009?
Provide a short and direct response. 0.62. What is the ratio of the Trade (in US$) of Kiribati in 2005 to that in 2009?
Offer a terse response. 0.82. What is the ratio of the Trade (in US$) of Romania in 2005 to that in 2009?
Ensure brevity in your answer.  0.72. What is the ratio of the Trade (in US$) in Venezuela in 2005 to that in 2009?
Provide a short and direct response. 0.97. What is the ratio of the Trade (in US$) of Iraq in 2005 to that in 2010?
Provide a succinct answer. 0.5. What is the ratio of the Trade (in US$) in Kiribati in 2005 to that in 2010?
Provide a short and direct response. 0.92. What is the ratio of the Trade (in US$) in Romania in 2005 to that in 2010?
Provide a short and direct response. 0.6. What is the ratio of the Trade (in US$) of Venezuela in 2005 to that in 2010?
Your answer should be very brief. 0.51. What is the ratio of the Trade (in US$) of Iraq in 2006 to that in 2007?
Provide a succinct answer. 0.82. What is the ratio of the Trade (in US$) in Kiribati in 2006 to that in 2007?
Your response must be concise. 0.55. What is the ratio of the Trade (in US$) in Romania in 2006 to that in 2007?
Offer a terse response. 0.79. What is the ratio of the Trade (in US$) in Venezuela in 2006 to that in 2007?
Ensure brevity in your answer.  0.93. What is the ratio of the Trade (in US$) in Iraq in 2006 to that in 2008?
Offer a very short reply. 0.5. What is the ratio of the Trade (in US$) of Kiribati in 2006 to that in 2008?
Ensure brevity in your answer.  0.6. What is the ratio of the Trade (in US$) of Romania in 2006 to that in 2008?
Keep it short and to the point. 0.71. What is the ratio of the Trade (in US$) of Venezuela in 2006 to that in 2008?
Provide a short and direct response. 0.69. What is the ratio of the Trade (in US$) of Iraq in 2006 to that in 2009?
Your answer should be very brief. 0.76. What is the ratio of the Trade (in US$) of Kiribati in 2006 to that in 2009?
Provide a succinct answer. 0.63. What is the ratio of the Trade (in US$) of Romania in 2006 to that in 2009?
Ensure brevity in your answer.  0.86. What is the ratio of the Trade (in US$) in Venezuela in 2006 to that in 2009?
Provide a short and direct response. 1.13. What is the ratio of the Trade (in US$) of Iraq in 2006 to that in 2010?
Provide a short and direct response. 0.61. What is the ratio of the Trade (in US$) in Kiribati in 2006 to that in 2010?
Offer a terse response. 0.7. What is the ratio of the Trade (in US$) of Romania in 2006 to that in 2010?
Provide a short and direct response. 0.73. What is the ratio of the Trade (in US$) of Venezuela in 2006 to that in 2010?
Your answer should be compact. 0.6. What is the ratio of the Trade (in US$) in Iraq in 2007 to that in 2008?
Your answer should be very brief. 0.62. What is the ratio of the Trade (in US$) of Kiribati in 2007 to that in 2008?
Provide a short and direct response. 1.1. What is the ratio of the Trade (in US$) in Romania in 2007 to that in 2008?
Your answer should be very brief. 0.89. What is the ratio of the Trade (in US$) of Venezuela in 2007 to that in 2008?
Provide a short and direct response. 0.74. What is the ratio of the Trade (in US$) in Iraq in 2007 to that in 2009?
Offer a very short reply. 0.93. What is the ratio of the Trade (in US$) of Kiribati in 2007 to that in 2009?
Offer a very short reply. 1.14. What is the ratio of the Trade (in US$) of Venezuela in 2007 to that in 2009?
Make the answer very short. 1.2. What is the ratio of the Trade (in US$) of Iraq in 2007 to that in 2010?
Provide a succinct answer. 0.75. What is the ratio of the Trade (in US$) in Kiribati in 2007 to that in 2010?
Offer a very short reply. 1.27. What is the ratio of the Trade (in US$) in Romania in 2007 to that in 2010?
Your answer should be very brief. 0.92. What is the ratio of the Trade (in US$) of Venezuela in 2007 to that in 2010?
Offer a very short reply. 0.64. What is the ratio of the Trade (in US$) of Iraq in 2008 to that in 2009?
Provide a succinct answer. 1.51. What is the ratio of the Trade (in US$) in Kiribati in 2008 to that in 2009?
Provide a short and direct response. 1.04. What is the ratio of the Trade (in US$) of Romania in 2008 to that in 2009?
Keep it short and to the point. 1.22. What is the ratio of the Trade (in US$) of Venezuela in 2008 to that in 2009?
Provide a short and direct response. 1.63. What is the ratio of the Trade (in US$) in Iraq in 2008 to that in 2010?
Give a very brief answer. 1.21. What is the ratio of the Trade (in US$) of Kiribati in 2008 to that in 2010?
Your response must be concise. 1.16. What is the ratio of the Trade (in US$) in Venezuela in 2008 to that in 2010?
Provide a short and direct response. 0.87. What is the ratio of the Trade (in US$) in Iraq in 2009 to that in 2010?
Provide a short and direct response. 0.81. What is the ratio of the Trade (in US$) in Kiribati in 2009 to that in 2010?
Make the answer very short. 1.12. What is the ratio of the Trade (in US$) of Romania in 2009 to that in 2010?
Keep it short and to the point. 0.84. What is the ratio of the Trade (in US$) in Venezuela in 2009 to that in 2010?
Make the answer very short. 0.53. What is the difference between the highest and the second highest Trade (in US$) of Iraq?
Provide a succinct answer. 1.16e+1. What is the difference between the highest and the second highest Trade (in US$) of Kiribati?
Provide a succinct answer. 1.82e+06. What is the difference between the highest and the second highest Trade (in US$) in Romania?
Provide a succinct answer. 1.81e+09. What is the difference between the highest and the second highest Trade (in US$) in Venezuela?
Ensure brevity in your answer.  1.51e+1. What is the difference between the highest and the lowest Trade (in US$) in Iraq?
Provide a short and direct response. 4.56e+1. What is the difference between the highest and the lowest Trade (in US$) of Kiribati?
Provide a short and direct response. 9.38e+06. What is the difference between the highest and the lowest Trade (in US$) of Romania?
Your response must be concise. 2.89e+1. What is the difference between the highest and the lowest Trade (in US$) of Venezuela?
Your response must be concise. 7.16e+1. 